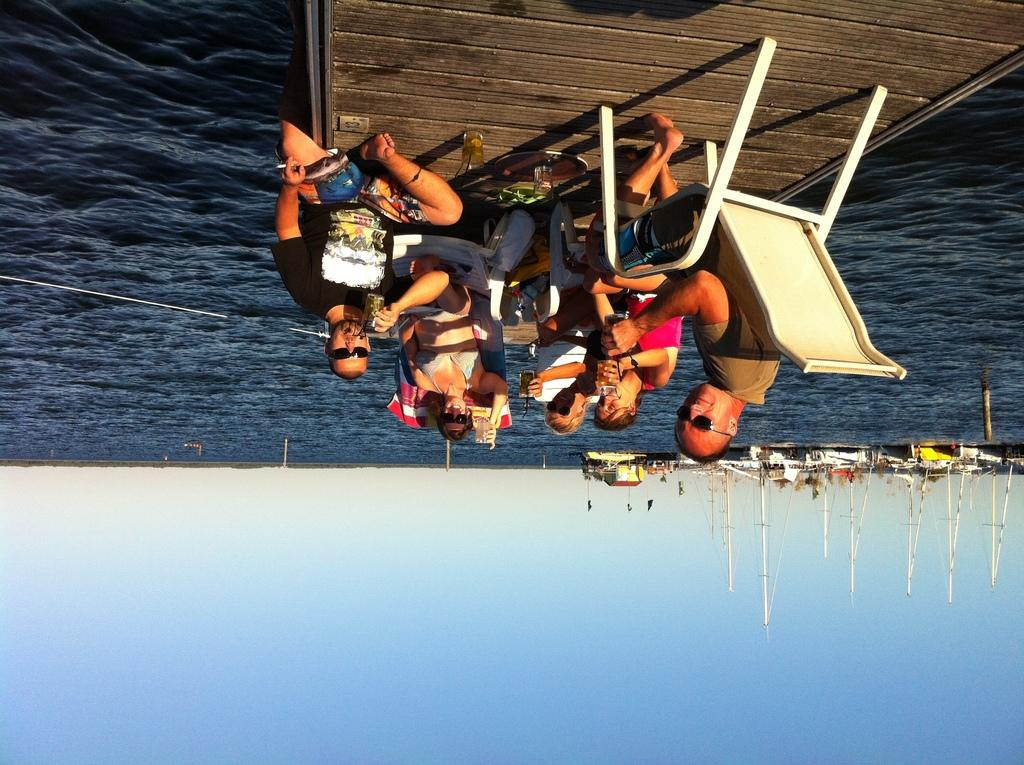What type of structure is present in the picture? There is a wooden bridge in the picture. What are the people in the picture doing? The people in the picture are sitting on chairs. What can be seen moving on the water in the image? Boats are sailing on the water at the right side of the image. How would you describe the weather based on the image? The sky is clear in the image, suggesting good weather. What color is the guide's shirt in the image? There is no guide present in the image, so it is not possible to determine the color of their shirt. 